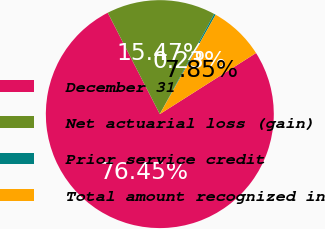Convert chart. <chart><loc_0><loc_0><loc_500><loc_500><pie_chart><fcel>December 31<fcel>Net actuarial loss (gain)<fcel>Prior service credit<fcel>Total amount recognized in<nl><fcel>76.45%<fcel>15.47%<fcel>0.23%<fcel>7.85%<nl></chart> 